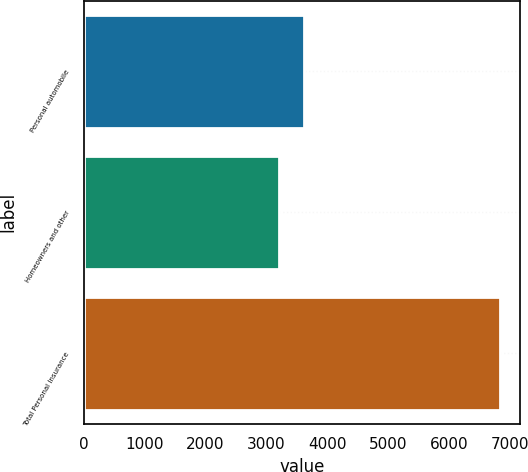<chart> <loc_0><loc_0><loc_500><loc_500><bar_chart><fcel>Personal automobile<fcel>Homeowners and other<fcel>Total Personal Insurance<nl><fcel>3628<fcel>3207<fcel>6835<nl></chart> 